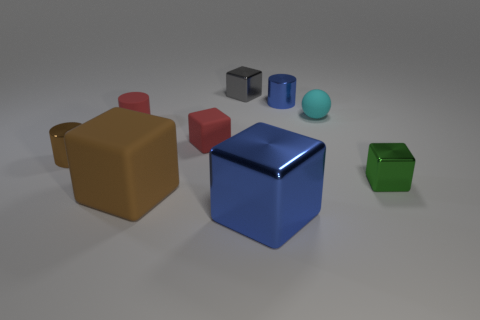There is a tiny metal thing that is to the right of the tiny metallic cylinder on the right side of the brown block; how many small rubber cylinders are to the left of it?
Your answer should be compact. 1. The other big metallic thing that is the same shape as the green object is what color?
Provide a succinct answer. Blue. There is a small thing behind the metal cylinder right of the tiny red cylinder in front of the small blue object; what shape is it?
Give a very brief answer. Cube. How big is the metallic cube that is behind the large matte thing and in front of the small cyan thing?
Your answer should be very brief. Small. Is the number of large blue objects less than the number of large red rubber blocks?
Offer a terse response. No. How big is the red matte cylinder on the right side of the small brown metal cylinder?
Make the answer very short. Small. What shape is the tiny shiny thing that is in front of the tiny red matte cube and to the right of the gray thing?
Provide a succinct answer. Cube. What is the size of the other matte thing that is the same shape as the brown rubber thing?
Offer a terse response. Small. How many small cubes have the same material as the green object?
Your response must be concise. 1. There is a big metal block; does it have the same color as the small shiny cylinder on the right side of the big metal object?
Your answer should be compact. Yes. 